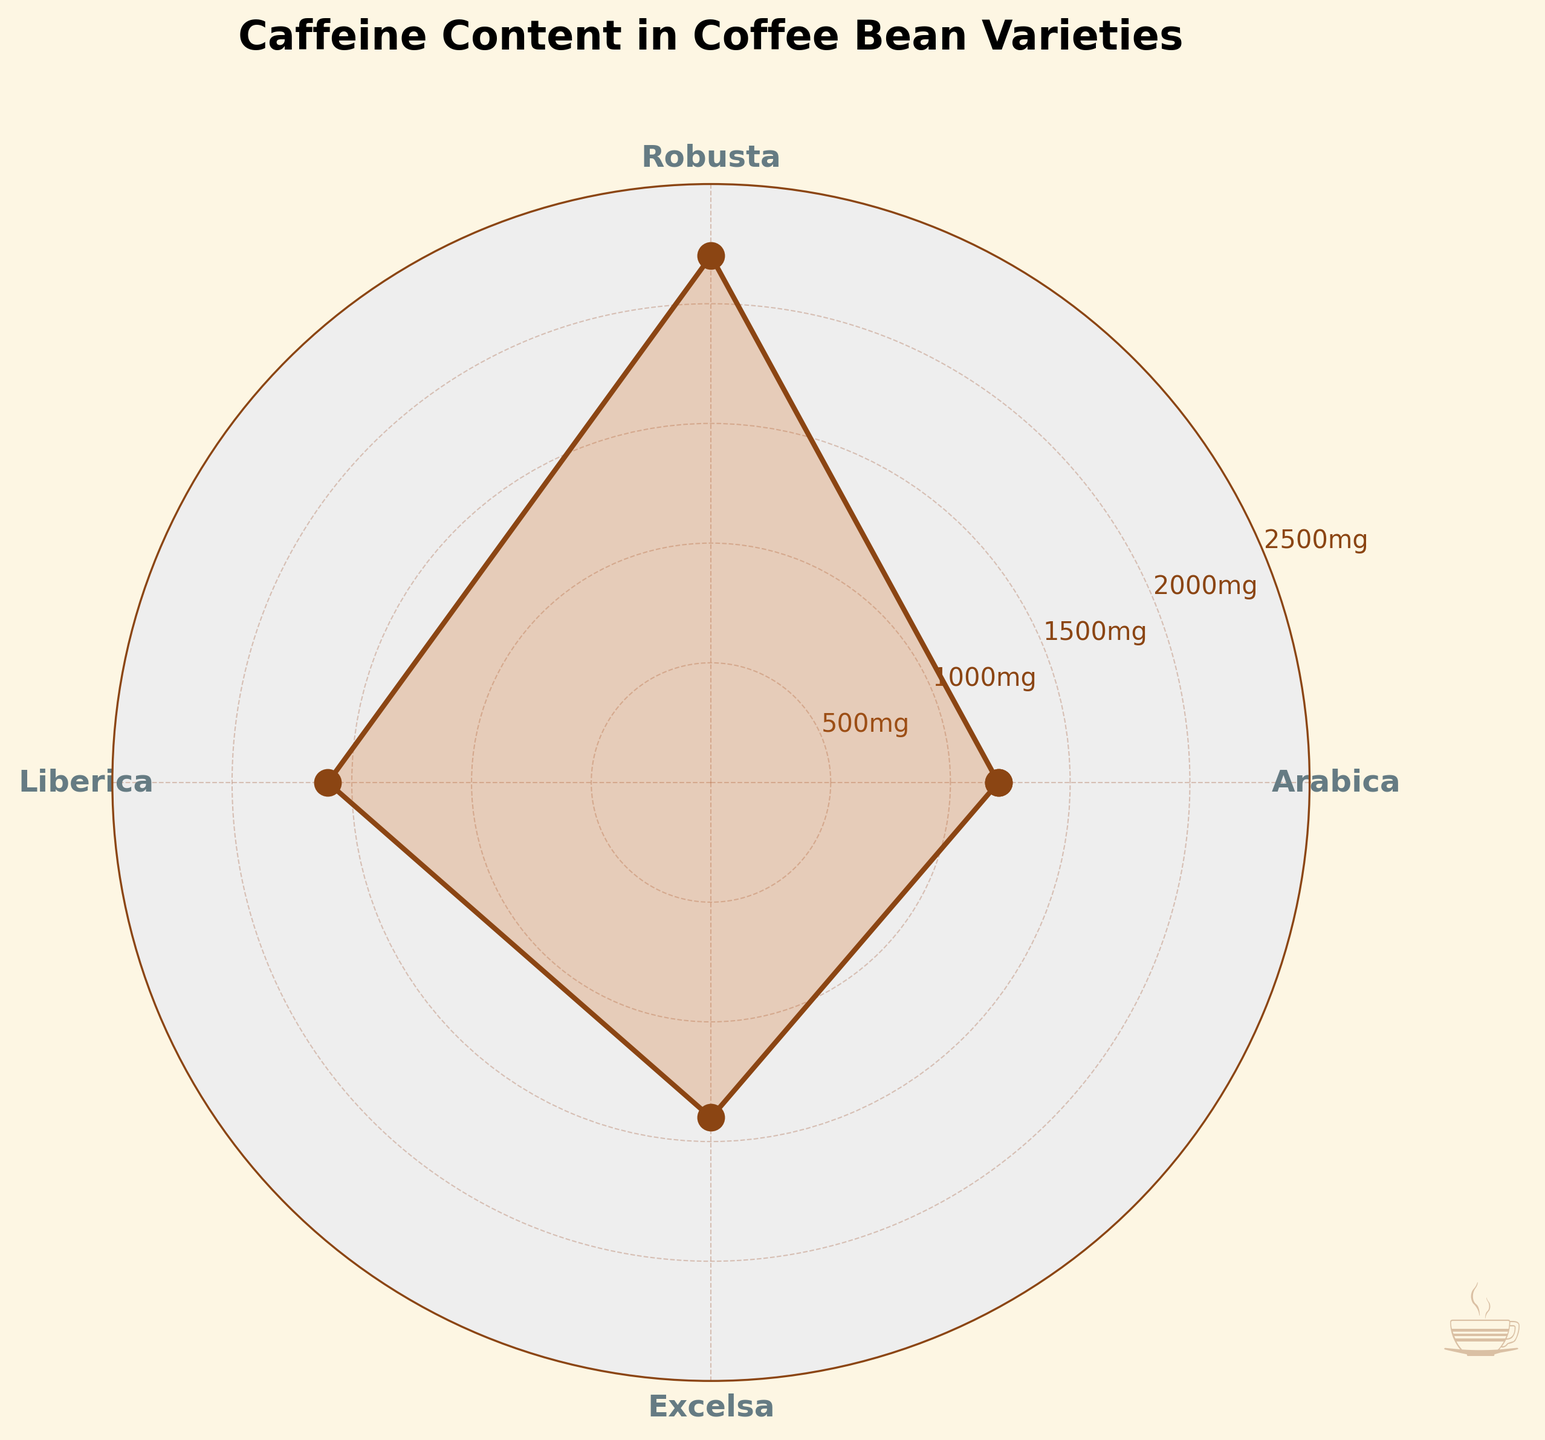How many coffee bean varieties are shown in the chart? The chart has four distinct segments, each labeled with a coffee bean variety name.
Answer: 4 Which coffee bean variety has the highest caffeine content? The variety with the longest segment extending towards the outer edge of the chart is Robusta, which means it has the highest caffeine content.
Answer: Robusta What is the caffeine content of the Arabica variety? The corresponding segment for Arabica reaches up to the value marked on the y-axis. By identifying the label "Arabica" close to the center and tracing its segment, we see it extends to 1200 mg/100g.
Answer: 1200 mg/100g How much more caffeine does Robusta have compared to Arabica? Robusta has a caffeine content of 2200 mg/100g while Arabica has 1200 mg/100g. Subtracting these (2200 - 1200) gives the difference.
Answer: 1000 mg/100g Which coffee bean variety has the lowest caffeine content? The variety with the shortest segment towards the inner edge of the chart is Arabica.
Answer: Arabica What is the average caffeine content of all coffee bean varieties shown? Add all the caffeine contents: 1200 (Arabica) + 2200 (Robusta) + 1600 (Liberica) + 1400 (Excelsa) = 6400. Then divide by the number of varieties (4). The average caffeine content is 6400/4.
Answer: 1600 mg/100g What is the sum of the caffeine content values for Liberica and Excelsa? Add the caffeine contents of both varieties: 1600 mg/100g (Liberica) + 1400 mg/100g (Excelsa).
Answer: 3000 mg/100g Which two coffee bean varieties have the closest caffeine content values? Comparing the lengths of the segments, Liberica and Excelsa have the closest values with 1600 mg/100g and 1400 mg/100g respectively.
Answer: Liberica and Excelsa Is the caffeine content in Excelsa greater than the average caffeine content of these varieties? The average caffeine content is 1600 mg/100g. Comparing this with the caffeine content of Excelsa (1400 mg/100g) shows that it is less.
Answer: No What is the color used for filling the segments in the chart? The segments are filled with a light brown color, which enhances the coffee theme of the plot.
Answer: Light brown 